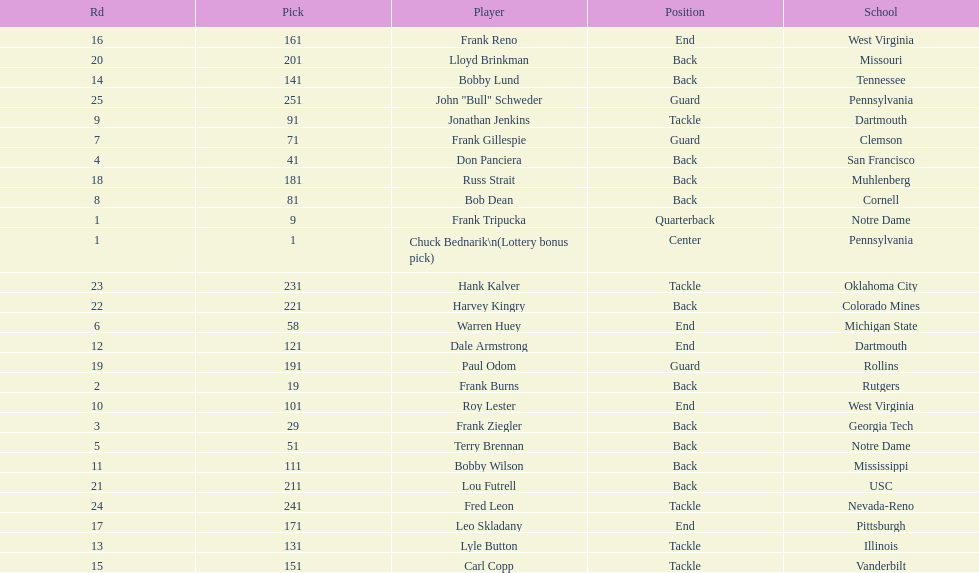Was chuck bednarik or frank tripucka the first draft pick? Chuck Bednarik. 